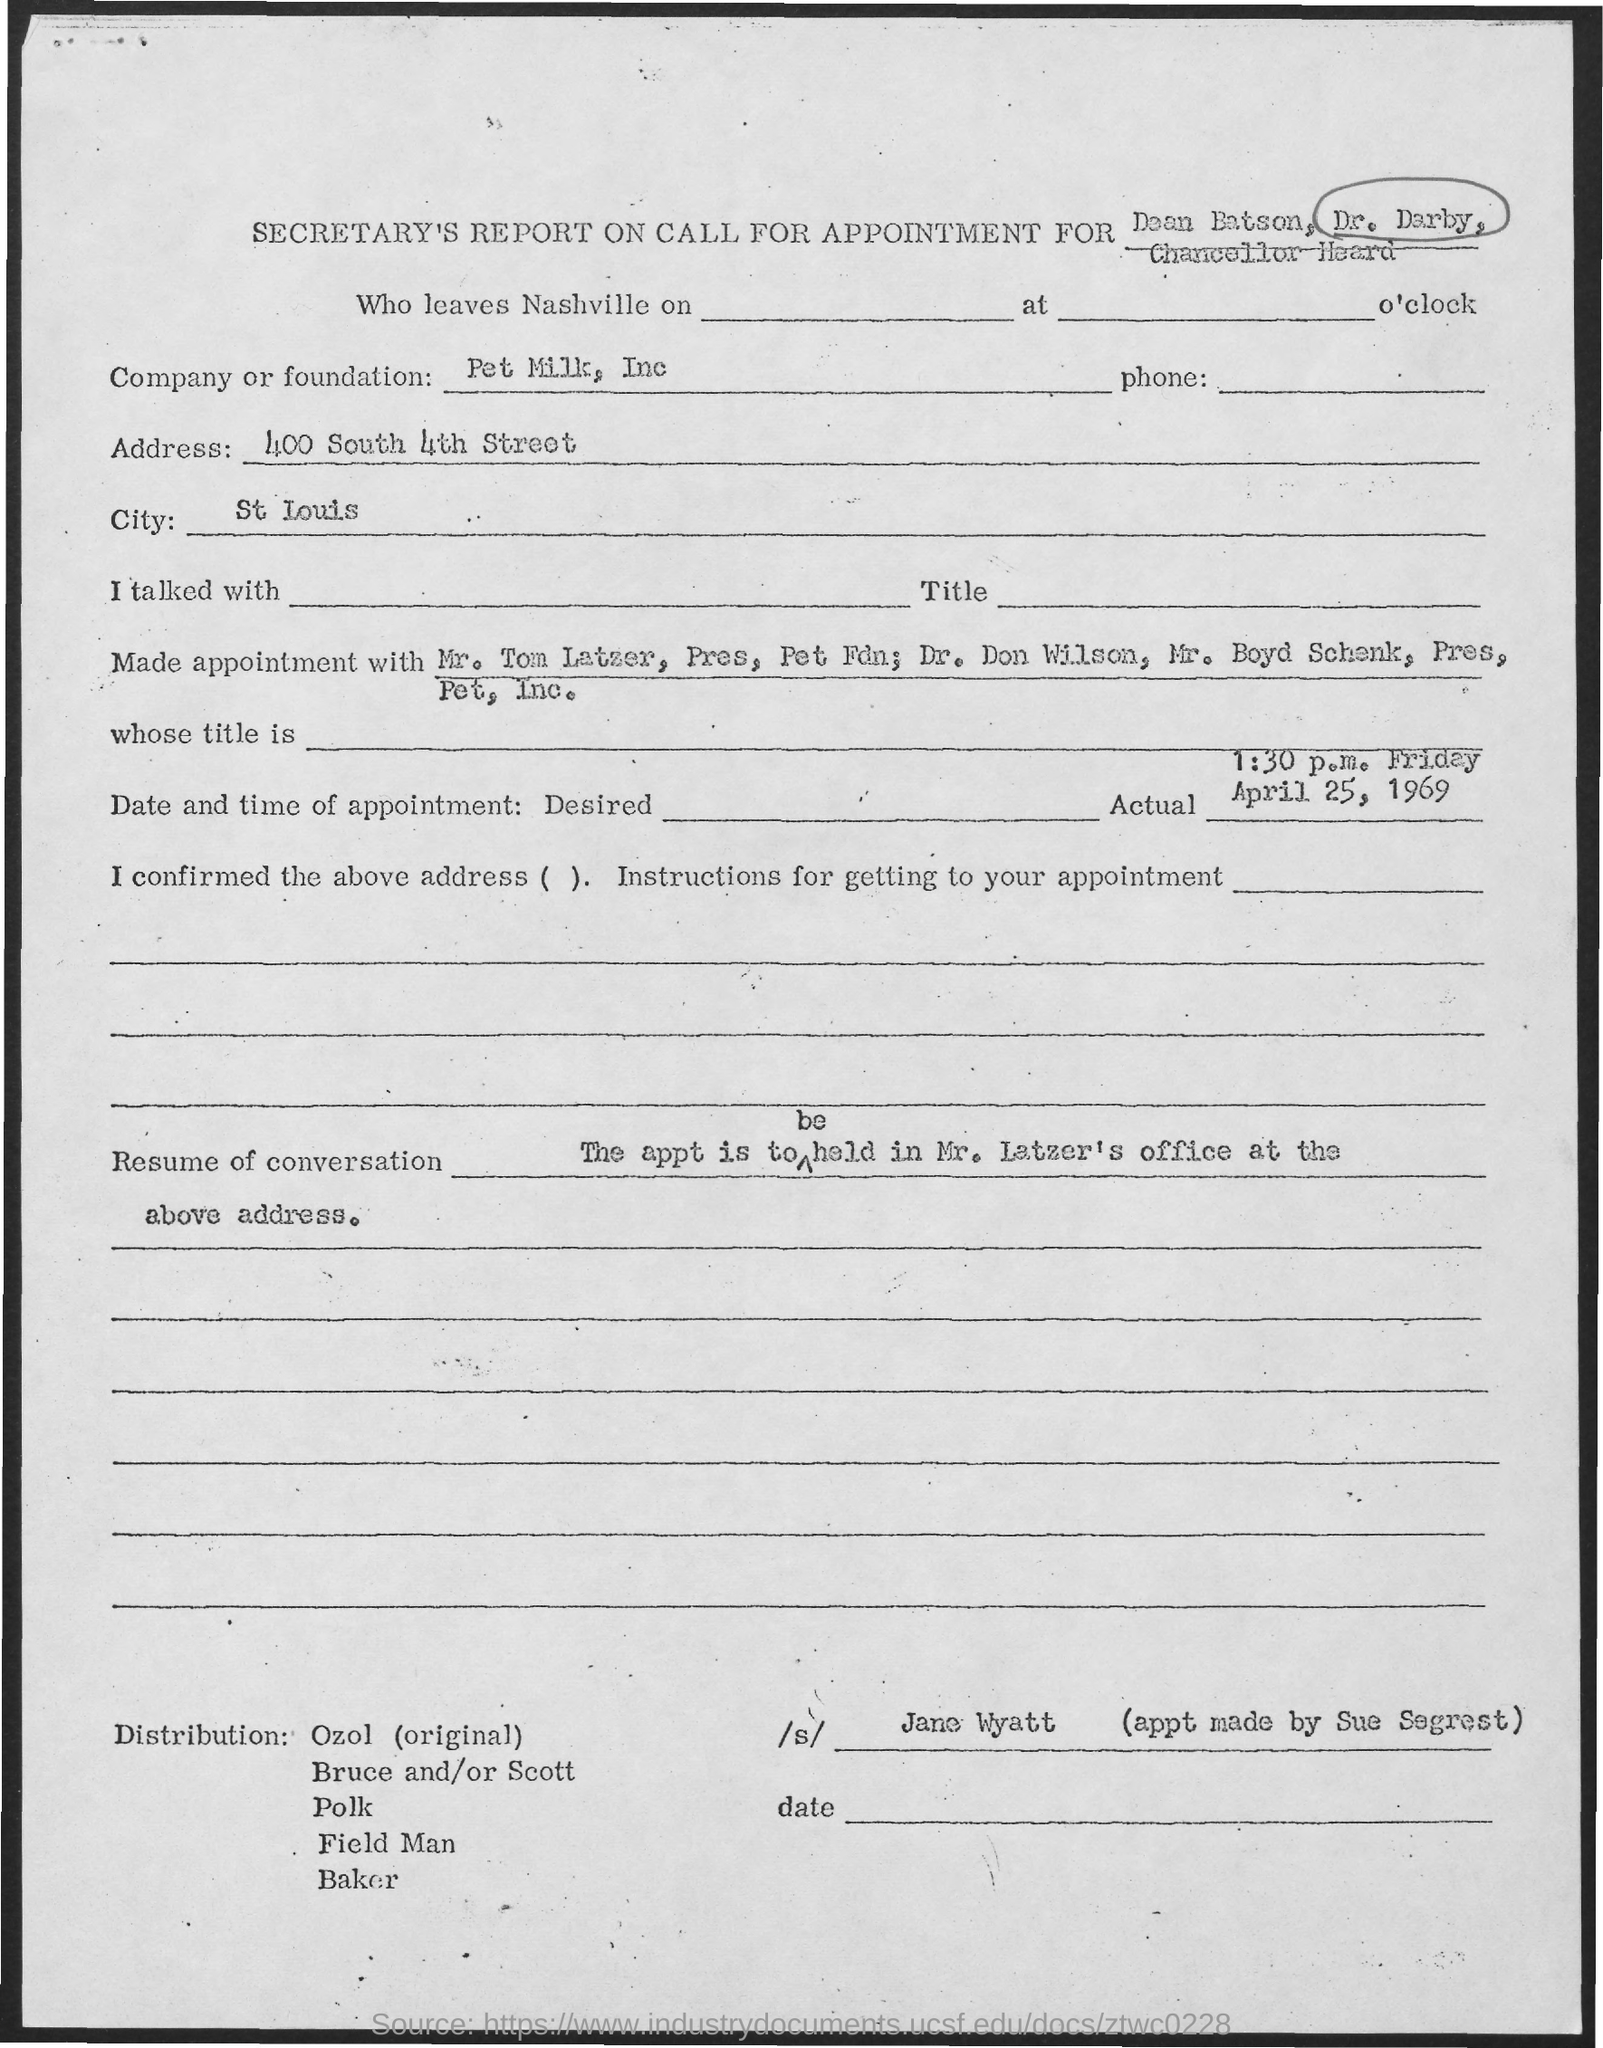What is the Company or foundation?
Your answer should be compact. Pet milk, inc. What is the Address?
Provide a succinct answer. 400 South 4th street. What is the City?
Ensure brevity in your answer.  St louis. What is the Actual date and time of appointment?
Ensure brevity in your answer.  1:30 p.m. Friday April 25, 1969. Who made the appt?
Offer a very short reply. Sue segrest. 